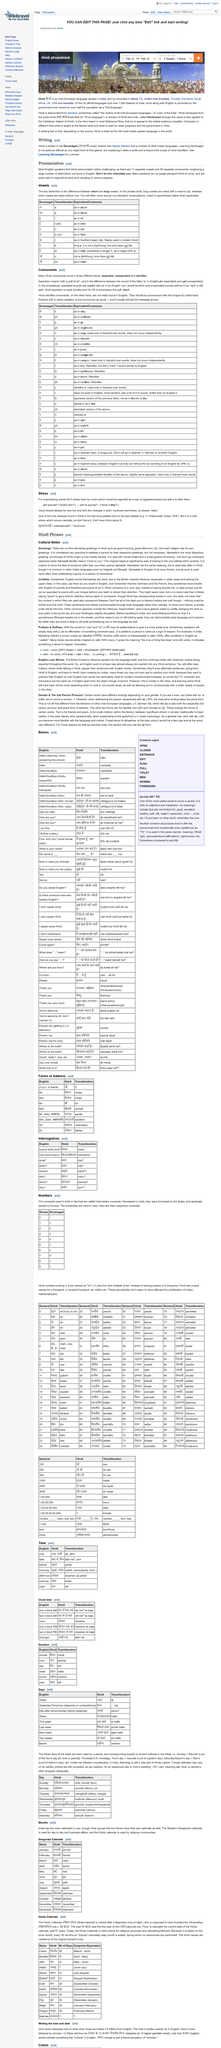List a handful of essential elements in this visual. Namaste," which is a greeting of Hindi origin, is the most ubiquitous greeting in the Hindi language. The use of time elemental greetings is not commonly found in Hindi. The literal translation of the greeting "Namaste" is "I bow to you. 